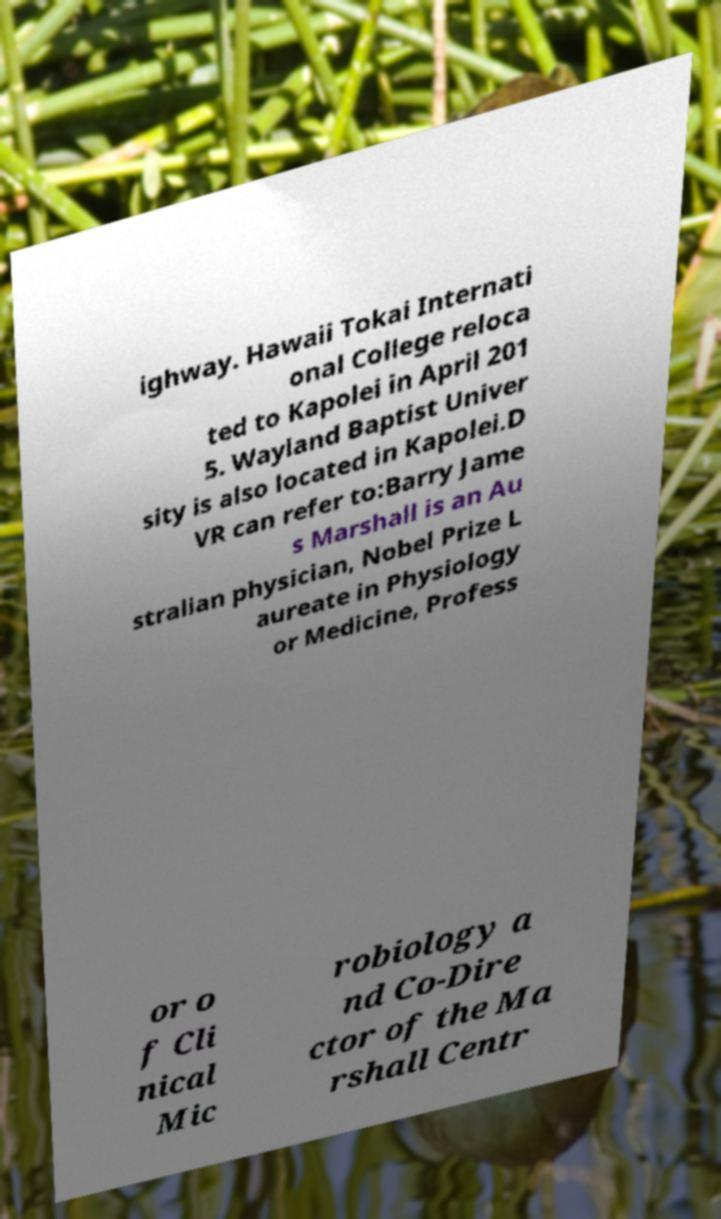I need the written content from this picture converted into text. Can you do that? ighway. Hawaii Tokai Internati onal College reloca ted to Kapolei in April 201 5. Wayland Baptist Univer sity is also located in Kapolei.D VR can refer to:Barry Jame s Marshall is an Au stralian physician, Nobel Prize L aureate in Physiology or Medicine, Profess or o f Cli nical Mic robiology a nd Co-Dire ctor of the Ma rshall Centr 